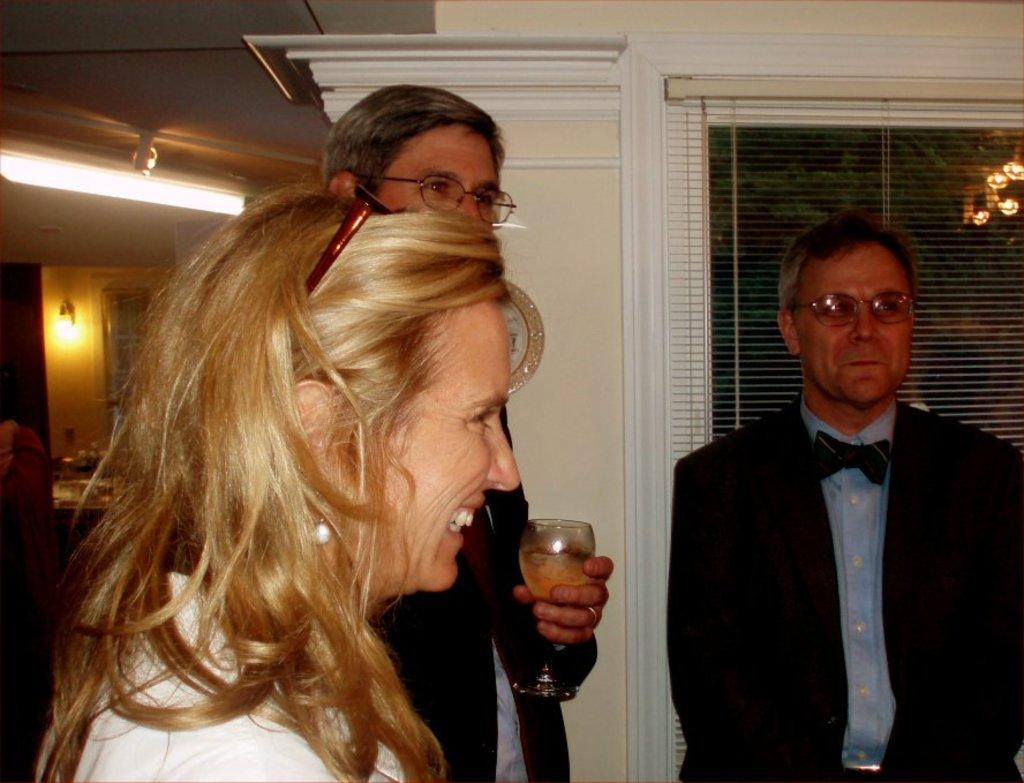How many people are in the image? There are three people in the image: one woman and two men. What is one of the men holding in the image? One of the men is holding a wine glass. What can be seen in the background of the image? There is a window, a wall, and lights visible in the background of the image. What type of sack can be seen hanging from the wall in the image? There is no sack hanging from the wall in the image. Can you describe the rock formation visible through the window in the image? There is no rock formation visible through the window in the image. 